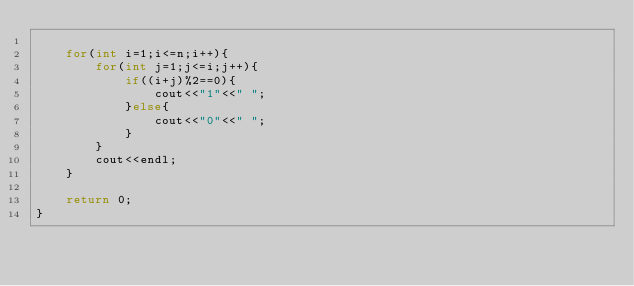Convert code to text. <code><loc_0><loc_0><loc_500><loc_500><_C++_>
    for(int i=1;i<=n;i++){
        for(int j=1;j<=i;j++){
            if((i+j)%2==0){
                cout<<"1"<<" ";
            }else{
                cout<<"0"<<" ";
            }
        }
        cout<<endl;
    }

    return 0;
}</code> 